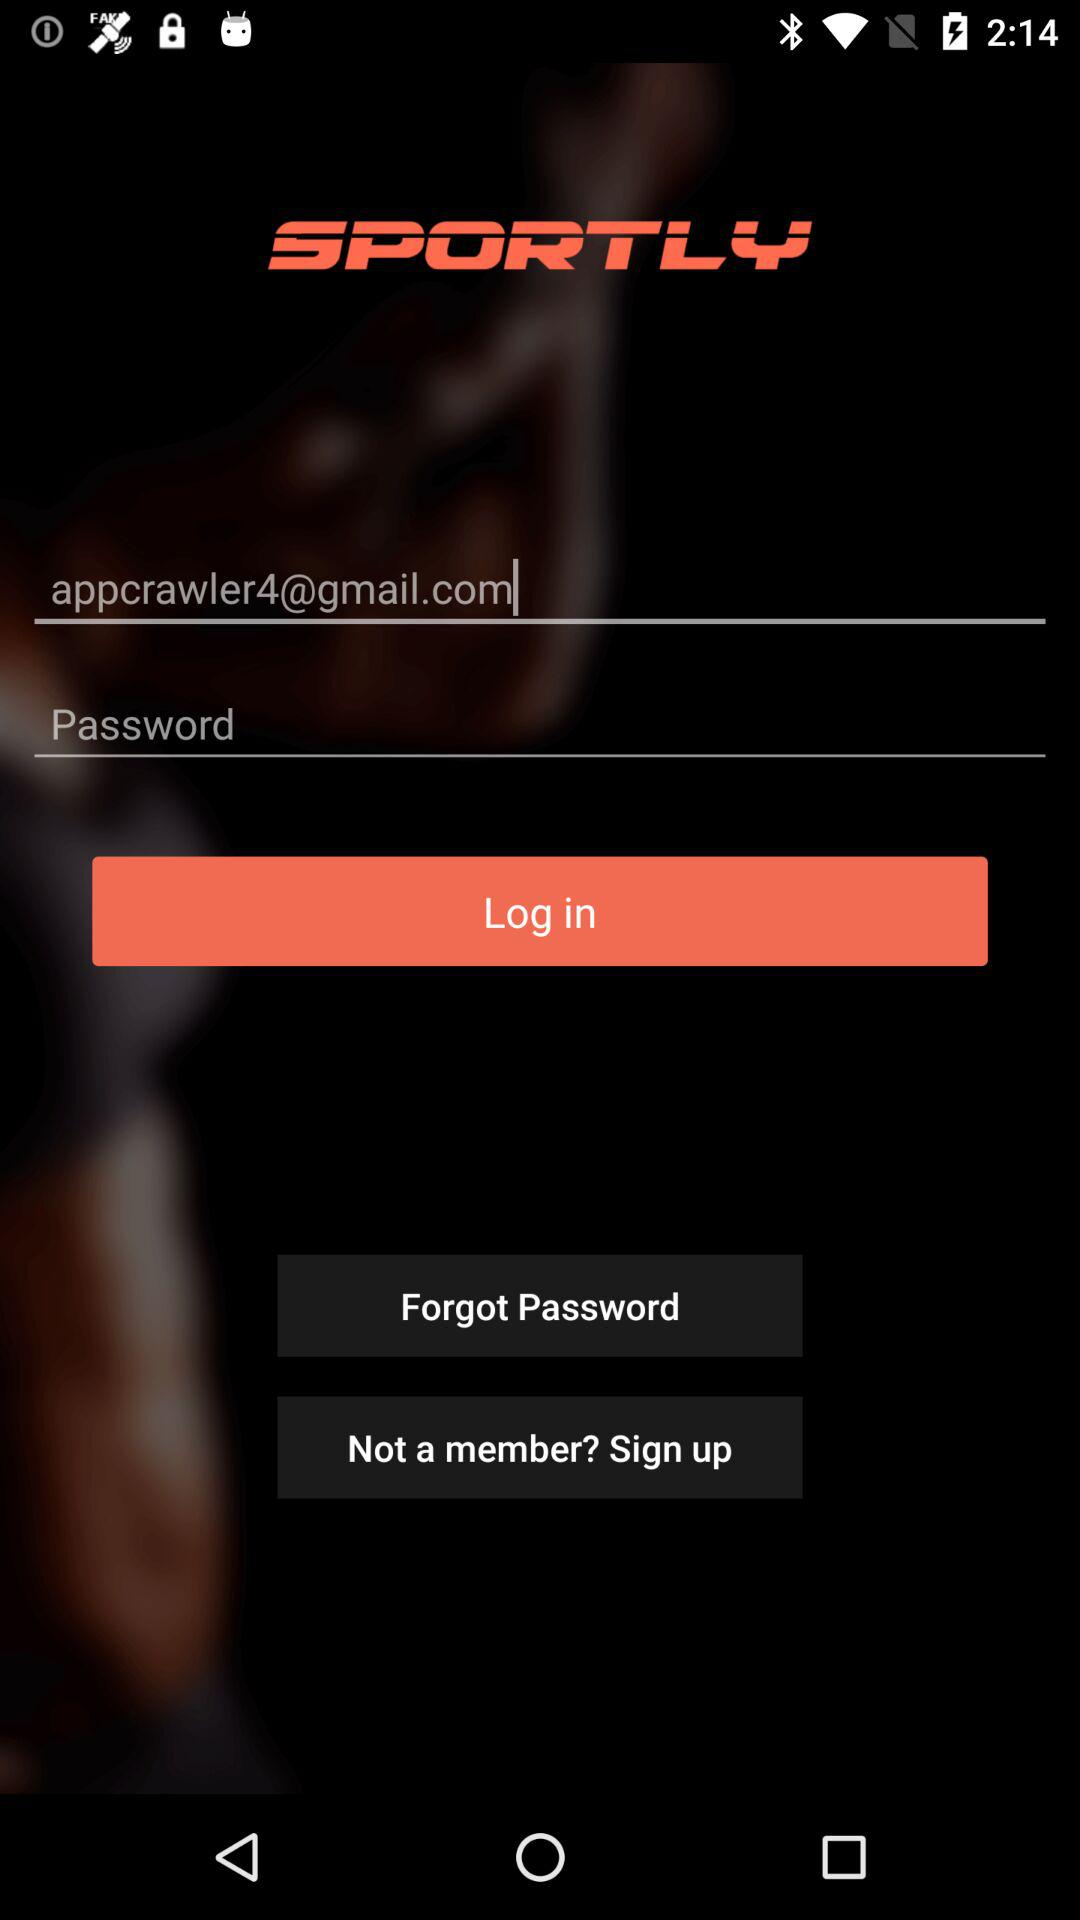What is the name of the application? The name of the application is "SPORTLY". 